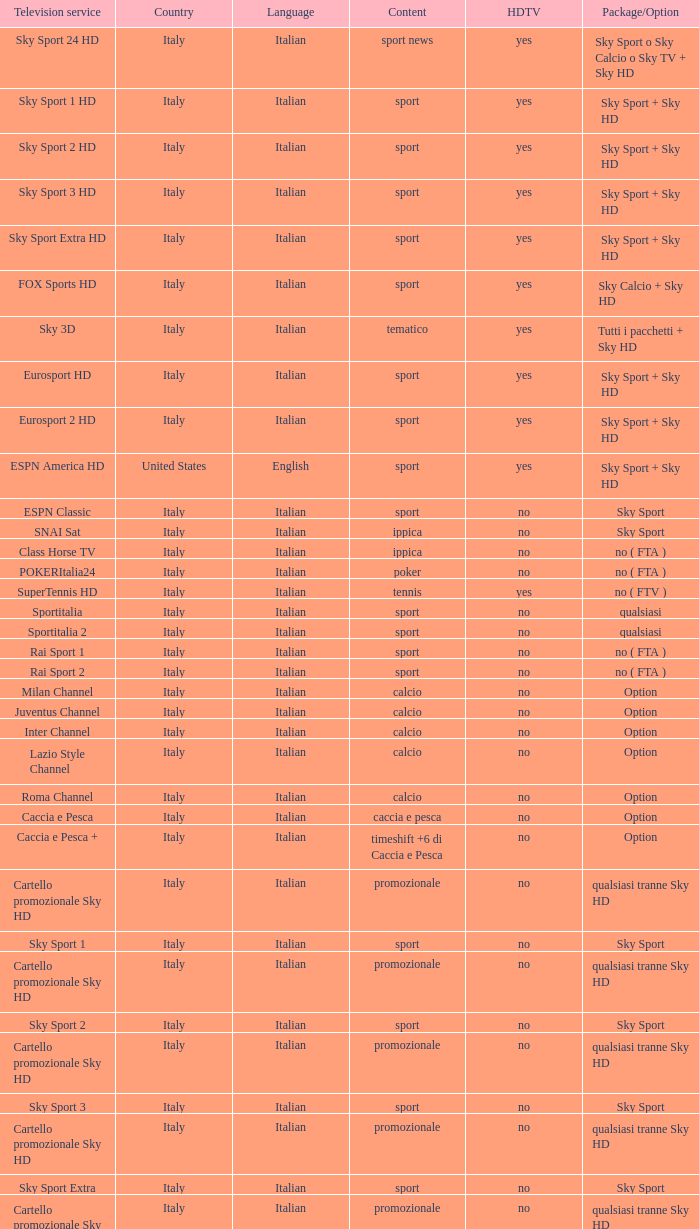What is Television Service, when Content is Calcio, and when Package/Option is Option? Milan Channel, Juventus Channel, Inter Channel, Lazio Style Channel, Roma Channel. 